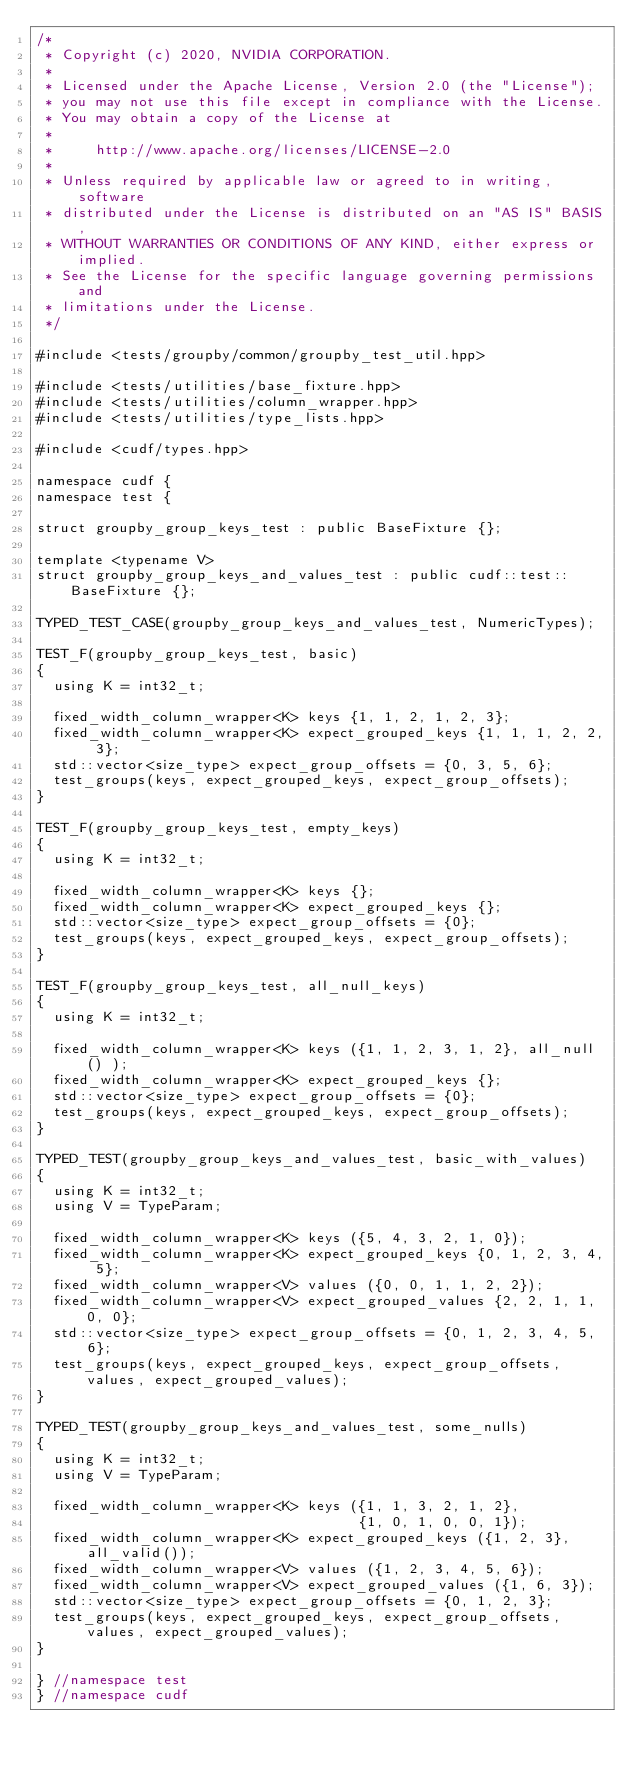Convert code to text. <code><loc_0><loc_0><loc_500><loc_500><_Cuda_>/*
 * Copyright (c) 2020, NVIDIA CORPORATION.
 *
 * Licensed under the Apache License, Version 2.0 (the "License");
 * you may not use this file except in compliance with the License.
 * You may obtain a copy of the License at
 *
 *     http://www.apache.org/licenses/LICENSE-2.0
 *
 * Unless required by applicable law or agreed to in writing, software
 * distributed under the License is distributed on an "AS IS" BASIS,
 * WITHOUT WARRANTIES OR CONDITIONS OF ANY KIND, either express or implied.
 * See the License for the specific language governing permissions and
 * limitations under the License.
 */

#include <tests/groupby/common/groupby_test_util.hpp>

#include <tests/utilities/base_fixture.hpp>
#include <tests/utilities/column_wrapper.hpp>
#include <tests/utilities/type_lists.hpp>

#include <cudf/types.hpp>

namespace cudf {
namespace test {

struct groupby_group_keys_test : public BaseFixture {};

template <typename V>
struct groupby_group_keys_and_values_test : public cudf::test::BaseFixture {};

TYPED_TEST_CASE(groupby_group_keys_and_values_test, NumericTypes);

TEST_F(groupby_group_keys_test, basic)
{
  using K = int32_t;

  fixed_width_column_wrapper<K> keys {1, 1, 2, 1, 2, 3};
  fixed_width_column_wrapper<K> expect_grouped_keys {1, 1, 1, 2, 2, 3};
  std::vector<size_type> expect_group_offsets = {0, 3, 5, 6};
  test_groups(keys, expect_grouped_keys, expect_group_offsets);
}

TEST_F(groupby_group_keys_test, empty_keys)
{
  using K = int32_t;

  fixed_width_column_wrapper<K> keys {};
  fixed_width_column_wrapper<K> expect_grouped_keys {};
  std::vector<size_type> expect_group_offsets = {0};
  test_groups(keys, expect_grouped_keys, expect_group_offsets);
}

TEST_F(groupby_group_keys_test, all_null_keys)
{
  using K = int32_t;

  fixed_width_column_wrapper<K> keys ({1, 1, 2, 3, 1, 2}, all_null() );
  fixed_width_column_wrapper<K> expect_grouped_keys {};
  std::vector<size_type> expect_group_offsets = {0};
  test_groups(keys, expect_grouped_keys, expect_group_offsets);
}

TYPED_TEST(groupby_group_keys_and_values_test, basic_with_values)
{
  using K = int32_t;
  using V = TypeParam;

  fixed_width_column_wrapper<K> keys ({5, 4, 3, 2, 1, 0});
  fixed_width_column_wrapper<K> expect_grouped_keys {0, 1, 2, 3, 4, 5};
  fixed_width_column_wrapper<V> values ({0, 0, 1, 1, 2, 2});
  fixed_width_column_wrapper<V> expect_grouped_values {2, 2, 1, 1, 0, 0};
  std::vector<size_type> expect_group_offsets = {0, 1, 2, 3, 4, 5, 6};
  test_groups(keys, expect_grouped_keys, expect_group_offsets, values, expect_grouped_values);
}

TYPED_TEST(groupby_group_keys_and_values_test, some_nulls)
{
  using K = int32_t;
  using V = TypeParam;

  fixed_width_column_wrapper<K> keys ({1, 1, 3, 2, 1, 2},
                                      {1, 0, 1, 0, 0, 1});
  fixed_width_column_wrapper<K> expect_grouped_keys ({1, 2, 3}, all_valid());
  fixed_width_column_wrapper<V> values ({1, 2, 3, 4, 5, 6});
  fixed_width_column_wrapper<V> expect_grouped_values ({1, 6, 3});
  std::vector<size_type> expect_group_offsets = {0, 1, 2, 3};
  test_groups(keys, expect_grouped_keys, expect_group_offsets, values, expect_grouped_values);
}

} //namespace test
} //namespace cudf
</code> 